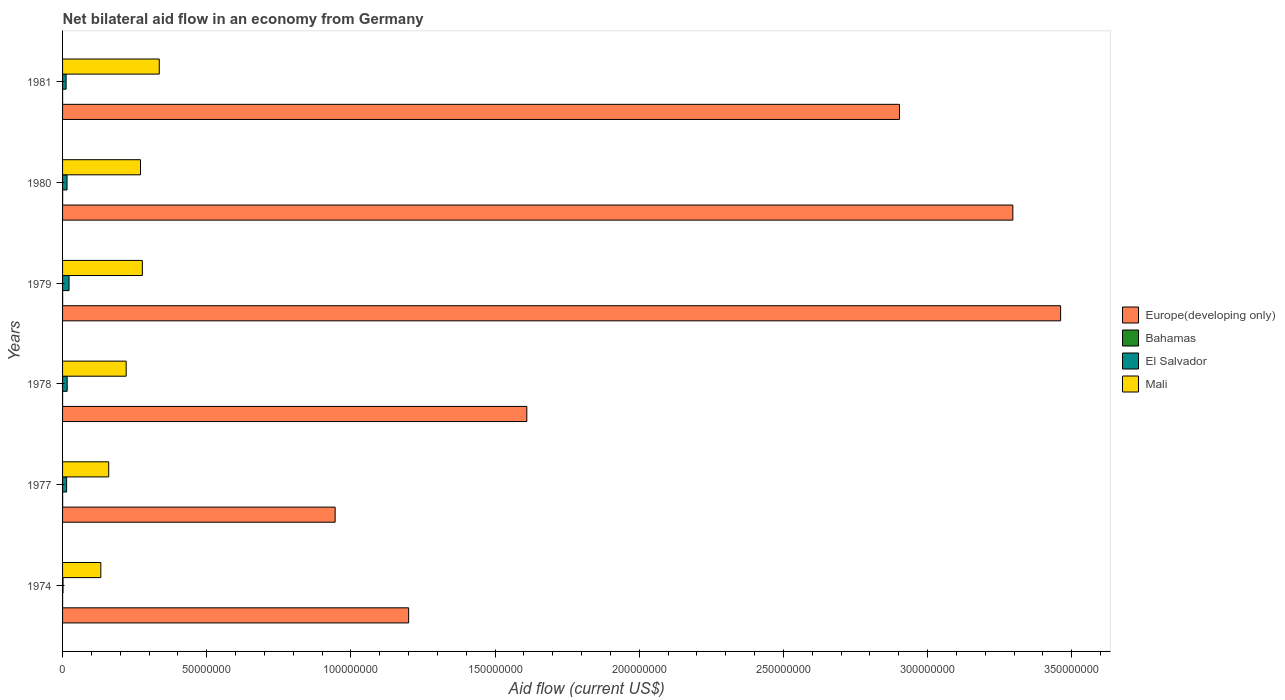How many different coloured bars are there?
Your answer should be compact. 4. Are the number of bars per tick equal to the number of legend labels?
Offer a terse response. Yes. How many bars are there on the 4th tick from the top?
Keep it short and to the point. 4. How many bars are there on the 5th tick from the bottom?
Give a very brief answer. 4. What is the label of the 5th group of bars from the top?
Ensure brevity in your answer.  1977. What is the net bilateral aid flow in Europe(developing only) in 1978?
Your answer should be compact. 1.61e+08. Across all years, what is the maximum net bilateral aid flow in Europe(developing only)?
Ensure brevity in your answer.  3.46e+08. Across all years, what is the minimum net bilateral aid flow in Mali?
Your response must be concise. 1.33e+07. In which year was the net bilateral aid flow in Bahamas maximum?
Your response must be concise. 1977. In which year was the net bilateral aid flow in Mali minimum?
Offer a very short reply. 1974. What is the total net bilateral aid flow in Europe(developing only) in the graph?
Your answer should be very brief. 1.34e+09. What is the difference between the net bilateral aid flow in Mali in 1977 and that in 1978?
Provide a short and direct response. -6.06e+06. What is the difference between the net bilateral aid flow in Mali in 1980 and the net bilateral aid flow in Bahamas in 1978?
Offer a terse response. 2.70e+07. What is the average net bilateral aid flow in Bahamas per year?
Ensure brevity in your answer.  1.50e+04. In the year 1981, what is the difference between the net bilateral aid flow in Bahamas and net bilateral aid flow in Europe(developing only)?
Keep it short and to the point. -2.90e+08. In how many years, is the net bilateral aid flow in Europe(developing only) greater than 290000000 US$?
Offer a terse response. 3. What is the ratio of the net bilateral aid flow in Bahamas in 1978 to that in 1979?
Your response must be concise. 0.5. Is the net bilateral aid flow in El Salvador in 1974 less than that in 1978?
Offer a very short reply. Yes. What is the difference between the highest and the second highest net bilateral aid flow in Europe(developing only)?
Your response must be concise. 1.66e+07. In how many years, is the net bilateral aid flow in Bahamas greater than the average net bilateral aid flow in Bahamas taken over all years?
Your answer should be compact. 3. Is the sum of the net bilateral aid flow in Bahamas in 1977 and 1981 greater than the maximum net bilateral aid flow in El Salvador across all years?
Offer a terse response. No. Is it the case that in every year, the sum of the net bilateral aid flow in Europe(developing only) and net bilateral aid flow in Mali is greater than the sum of net bilateral aid flow in Bahamas and net bilateral aid flow in El Salvador?
Your answer should be compact. No. What does the 4th bar from the top in 1979 represents?
Make the answer very short. Europe(developing only). What does the 2nd bar from the bottom in 1977 represents?
Your answer should be compact. Bahamas. Is it the case that in every year, the sum of the net bilateral aid flow in Bahamas and net bilateral aid flow in Mali is greater than the net bilateral aid flow in Europe(developing only)?
Your answer should be very brief. No. How many bars are there?
Your answer should be compact. 24. Are all the bars in the graph horizontal?
Keep it short and to the point. Yes. How many years are there in the graph?
Offer a very short reply. 6. What is the difference between two consecutive major ticks on the X-axis?
Your answer should be very brief. 5.00e+07. Does the graph contain grids?
Your answer should be very brief. No. How many legend labels are there?
Provide a succinct answer. 4. How are the legend labels stacked?
Make the answer very short. Vertical. What is the title of the graph?
Make the answer very short. Net bilateral aid flow in an economy from Germany. Does "Croatia" appear as one of the legend labels in the graph?
Offer a terse response. No. What is the label or title of the X-axis?
Make the answer very short. Aid flow (current US$). What is the label or title of the Y-axis?
Offer a very short reply. Years. What is the Aid flow (current US$) in Europe(developing only) in 1974?
Provide a short and direct response. 1.20e+08. What is the Aid flow (current US$) in Bahamas in 1974?
Give a very brief answer. 10000. What is the Aid flow (current US$) in El Salvador in 1974?
Offer a very short reply. 1.60e+05. What is the Aid flow (current US$) in Mali in 1974?
Make the answer very short. 1.33e+07. What is the Aid flow (current US$) of Europe(developing only) in 1977?
Ensure brevity in your answer.  9.45e+07. What is the Aid flow (current US$) in El Salvador in 1977?
Your response must be concise. 1.41e+06. What is the Aid flow (current US$) in Mali in 1977?
Your response must be concise. 1.60e+07. What is the Aid flow (current US$) in Europe(developing only) in 1978?
Make the answer very short. 1.61e+08. What is the Aid flow (current US$) in Bahamas in 1978?
Provide a short and direct response. 10000. What is the Aid flow (current US$) of El Salvador in 1978?
Provide a short and direct response. 1.60e+06. What is the Aid flow (current US$) of Mali in 1978?
Your answer should be compact. 2.21e+07. What is the Aid flow (current US$) of Europe(developing only) in 1979?
Give a very brief answer. 3.46e+08. What is the Aid flow (current US$) in Bahamas in 1979?
Ensure brevity in your answer.  2.00e+04. What is the Aid flow (current US$) of El Salvador in 1979?
Keep it short and to the point. 2.25e+06. What is the Aid flow (current US$) in Mali in 1979?
Your answer should be compact. 2.77e+07. What is the Aid flow (current US$) in Europe(developing only) in 1980?
Provide a short and direct response. 3.30e+08. What is the Aid flow (current US$) of El Salvador in 1980?
Provide a succinct answer. 1.55e+06. What is the Aid flow (current US$) in Mali in 1980?
Keep it short and to the point. 2.70e+07. What is the Aid flow (current US$) of Europe(developing only) in 1981?
Your answer should be compact. 2.90e+08. What is the Aid flow (current US$) in El Salvador in 1981?
Make the answer very short. 1.23e+06. What is the Aid flow (current US$) in Mali in 1981?
Give a very brief answer. 3.35e+07. Across all years, what is the maximum Aid flow (current US$) of Europe(developing only)?
Make the answer very short. 3.46e+08. Across all years, what is the maximum Aid flow (current US$) in Bahamas?
Your response must be concise. 2.00e+04. Across all years, what is the maximum Aid flow (current US$) in El Salvador?
Your answer should be very brief. 2.25e+06. Across all years, what is the maximum Aid flow (current US$) in Mali?
Your answer should be compact. 3.35e+07. Across all years, what is the minimum Aid flow (current US$) of Europe(developing only)?
Make the answer very short. 9.45e+07. Across all years, what is the minimum Aid flow (current US$) of El Salvador?
Give a very brief answer. 1.60e+05. Across all years, what is the minimum Aid flow (current US$) of Mali?
Offer a very short reply. 1.33e+07. What is the total Aid flow (current US$) of Europe(developing only) in the graph?
Keep it short and to the point. 1.34e+09. What is the total Aid flow (current US$) of Bahamas in the graph?
Your response must be concise. 9.00e+04. What is the total Aid flow (current US$) of El Salvador in the graph?
Provide a short and direct response. 8.20e+06. What is the total Aid flow (current US$) of Mali in the graph?
Provide a succinct answer. 1.40e+08. What is the difference between the Aid flow (current US$) in Europe(developing only) in 1974 and that in 1977?
Your answer should be very brief. 2.55e+07. What is the difference between the Aid flow (current US$) of Bahamas in 1974 and that in 1977?
Provide a succinct answer. -10000. What is the difference between the Aid flow (current US$) of El Salvador in 1974 and that in 1977?
Give a very brief answer. -1.25e+06. What is the difference between the Aid flow (current US$) of Mali in 1974 and that in 1977?
Offer a very short reply. -2.73e+06. What is the difference between the Aid flow (current US$) of Europe(developing only) in 1974 and that in 1978?
Make the answer very short. -4.10e+07. What is the difference between the Aid flow (current US$) in El Salvador in 1974 and that in 1978?
Provide a succinct answer. -1.44e+06. What is the difference between the Aid flow (current US$) in Mali in 1974 and that in 1978?
Offer a very short reply. -8.79e+06. What is the difference between the Aid flow (current US$) of Europe(developing only) in 1974 and that in 1979?
Your answer should be very brief. -2.26e+08. What is the difference between the Aid flow (current US$) of Bahamas in 1974 and that in 1979?
Keep it short and to the point. -10000. What is the difference between the Aid flow (current US$) of El Salvador in 1974 and that in 1979?
Provide a short and direct response. -2.09e+06. What is the difference between the Aid flow (current US$) of Mali in 1974 and that in 1979?
Your response must be concise. -1.44e+07. What is the difference between the Aid flow (current US$) of Europe(developing only) in 1974 and that in 1980?
Your answer should be very brief. -2.10e+08. What is the difference between the Aid flow (current US$) in Bahamas in 1974 and that in 1980?
Offer a terse response. -10000. What is the difference between the Aid flow (current US$) of El Salvador in 1974 and that in 1980?
Your answer should be very brief. -1.39e+06. What is the difference between the Aid flow (current US$) of Mali in 1974 and that in 1980?
Your answer should be compact. -1.38e+07. What is the difference between the Aid flow (current US$) in Europe(developing only) in 1974 and that in 1981?
Your response must be concise. -1.70e+08. What is the difference between the Aid flow (current US$) in Bahamas in 1974 and that in 1981?
Keep it short and to the point. 0. What is the difference between the Aid flow (current US$) in El Salvador in 1974 and that in 1981?
Provide a succinct answer. -1.07e+06. What is the difference between the Aid flow (current US$) in Mali in 1974 and that in 1981?
Offer a very short reply. -2.03e+07. What is the difference between the Aid flow (current US$) of Europe(developing only) in 1977 and that in 1978?
Your answer should be compact. -6.65e+07. What is the difference between the Aid flow (current US$) in Bahamas in 1977 and that in 1978?
Provide a short and direct response. 10000. What is the difference between the Aid flow (current US$) in Mali in 1977 and that in 1978?
Make the answer very short. -6.06e+06. What is the difference between the Aid flow (current US$) of Europe(developing only) in 1977 and that in 1979?
Your answer should be very brief. -2.52e+08. What is the difference between the Aid flow (current US$) of Bahamas in 1977 and that in 1979?
Make the answer very short. 0. What is the difference between the Aid flow (current US$) in El Salvador in 1977 and that in 1979?
Provide a short and direct response. -8.40e+05. What is the difference between the Aid flow (current US$) of Mali in 1977 and that in 1979?
Provide a succinct answer. -1.17e+07. What is the difference between the Aid flow (current US$) in Europe(developing only) in 1977 and that in 1980?
Give a very brief answer. -2.35e+08. What is the difference between the Aid flow (current US$) in Mali in 1977 and that in 1980?
Your answer should be very brief. -1.10e+07. What is the difference between the Aid flow (current US$) of Europe(developing only) in 1977 and that in 1981?
Make the answer very short. -1.96e+08. What is the difference between the Aid flow (current US$) of Mali in 1977 and that in 1981?
Give a very brief answer. -1.75e+07. What is the difference between the Aid flow (current US$) in Europe(developing only) in 1978 and that in 1979?
Offer a terse response. -1.85e+08. What is the difference between the Aid flow (current US$) in El Salvador in 1978 and that in 1979?
Your response must be concise. -6.50e+05. What is the difference between the Aid flow (current US$) of Mali in 1978 and that in 1979?
Ensure brevity in your answer.  -5.61e+06. What is the difference between the Aid flow (current US$) of Europe(developing only) in 1978 and that in 1980?
Keep it short and to the point. -1.69e+08. What is the difference between the Aid flow (current US$) of El Salvador in 1978 and that in 1980?
Offer a very short reply. 5.00e+04. What is the difference between the Aid flow (current US$) in Mali in 1978 and that in 1980?
Make the answer very short. -4.97e+06. What is the difference between the Aid flow (current US$) in Europe(developing only) in 1978 and that in 1981?
Your response must be concise. -1.29e+08. What is the difference between the Aid flow (current US$) of El Salvador in 1978 and that in 1981?
Provide a short and direct response. 3.70e+05. What is the difference between the Aid flow (current US$) of Mali in 1978 and that in 1981?
Provide a short and direct response. -1.15e+07. What is the difference between the Aid flow (current US$) of Europe(developing only) in 1979 and that in 1980?
Offer a very short reply. 1.66e+07. What is the difference between the Aid flow (current US$) in El Salvador in 1979 and that in 1980?
Provide a short and direct response. 7.00e+05. What is the difference between the Aid flow (current US$) of Mali in 1979 and that in 1980?
Provide a short and direct response. 6.40e+05. What is the difference between the Aid flow (current US$) in Europe(developing only) in 1979 and that in 1981?
Your response must be concise. 5.59e+07. What is the difference between the Aid flow (current US$) in Bahamas in 1979 and that in 1981?
Your response must be concise. 10000. What is the difference between the Aid flow (current US$) in El Salvador in 1979 and that in 1981?
Provide a short and direct response. 1.02e+06. What is the difference between the Aid flow (current US$) in Mali in 1979 and that in 1981?
Your answer should be compact. -5.87e+06. What is the difference between the Aid flow (current US$) in Europe(developing only) in 1980 and that in 1981?
Offer a terse response. 3.93e+07. What is the difference between the Aid flow (current US$) of Bahamas in 1980 and that in 1981?
Make the answer very short. 10000. What is the difference between the Aid flow (current US$) of Mali in 1980 and that in 1981?
Provide a succinct answer. -6.51e+06. What is the difference between the Aid flow (current US$) in Europe(developing only) in 1974 and the Aid flow (current US$) in Bahamas in 1977?
Provide a succinct answer. 1.20e+08. What is the difference between the Aid flow (current US$) in Europe(developing only) in 1974 and the Aid flow (current US$) in El Salvador in 1977?
Your answer should be very brief. 1.19e+08. What is the difference between the Aid flow (current US$) of Europe(developing only) in 1974 and the Aid flow (current US$) of Mali in 1977?
Make the answer very short. 1.04e+08. What is the difference between the Aid flow (current US$) of Bahamas in 1974 and the Aid flow (current US$) of El Salvador in 1977?
Provide a short and direct response. -1.40e+06. What is the difference between the Aid flow (current US$) in Bahamas in 1974 and the Aid flow (current US$) in Mali in 1977?
Give a very brief answer. -1.60e+07. What is the difference between the Aid flow (current US$) in El Salvador in 1974 and the Aid flow (current US$) in Mali in 1977?
Keep it short and to the point. -1.58e+07. What is the difference between the Aid flow (current US$) in Europe(developing only) in 1974 and the Aid flow (current US$) in Bahamas in 1978?
Your answer should be very brief. 1.20e+08. What is the difference between the Aid flow (current US$) in Europe(developing only) in 1974 and the Aid flow (current US$) in El Salvador in 1978?
Provide a short and direct response. 1.18e+08. What is the difference between the Aid flow (current US$) in Europe(developing only) in 1974 and the Aid flow (current US$) in Mali in 1978?
Your response must be concise. 9.80e+07. What is the difference between the Aid flow (current US$) of Bahamas in 1974 and the Aid flow (current US$) of El Salvador in 1978?
Give a very brief answer. -1.59e+06. What is the difference between the Aid flow (current US$) in Bahamas in 1974 and the Aid flow (current US$) in Mali in 1978?
Ensure brevity in your answer.  -2.20e+07. What is the difference between the Aid flow (current US$) of El Salvador in 1974 and the Aid flow (current US$) of Mali in 1978?
Provide a succinct answer. -2.19e+07. What is the difference between the Aid flow (current US$) of Europe(developing only) in 1974 and the Aid flow (current US$) of Bahamas in 1979?
Your answer should be compact. 1.20e+08. What is the difference between the Aid flow (current US$) of Europe(developing only) in 1974 and the Aid flow (current US$) of El Salvador in 1979?
Ensure brevity in your answer.  1.18e+08. What is the difference between the Aid flow (current US$) in Europe(developing only) in 1974 and the Aid flow (current US$) in Mali in 1979?
Your response must be concise. 9.24e+07. What is the difference between the Aid flow (current US$) of Bahamas in 1974 and the Aid flow (current US$) of El Salvador in 1979?
Your answer should be compact. -2.24e+06. What is the difference between the Aid flow (current US$) in Bahamas in 1974 and the Aid flow (current US$) in Mali in 1979?
Provide a short and direct response. -2.77e+07. What is the difference between the Aid flow (current US$) of El Salvador in 1974 and the Aid flow (current US$) of Mali in 1979?
Ensure brevity in your answer.  -2.75e+07. What is the difference between the Aid flow (current US$) in Europe(developing only) in 1974 and the Aid flow (current US$) in Bahamas in 1980?
Your answer should be very brief. 1.20e+08. What is the difference between the Aid flow (current US$) in Europe(developing only) in 1974 and the Aid flow (current US$) in El Salvador in 1980?
Give a very brief answer. 1.18e+08. What is the difference between the Aid flow (current US$) of Europe(developing only) in 1974 and the Aid flow (current US$) of Mali in 1980?
Offer a terse response. 9.30e+07. What is the difference between the Aid flow (current US$) of Bahamas in 1974 and the Aid flow (current US$) of El Salvador in 1980?
Provide a short and direct response. -1.54e+06. What is the difference between the Aid flow (current US$) in Bahamas in 1974 and the Aid flow (current US$) in Mali in 1980?
Give a very brief answer. -2.70e+07. What is the difference between the Aid flow (current US$) of El Salvador in 1974 and the Aid flow (current US$) of Mali in 1980?
Your response must be concise. -2.69e+07. What is the difference between the Aid flow (current US$) in Europe(developing only) in 1974 and the Aid flow (current US$) in Bahamas in 1981?
Offer a terse response. 1.20e+08. What is the difference between the Aid flow (current US$) in Europe(developing only) in 1974 and the Aid flow (current US$) in El Salvador in 1981?
Make the answer very short. 1.19e+08. What is the difference between the Aid flow (current US$) in Europe(developing only) in 1974 and the Aid flow (current US$) in Mali in 1981?
Offer a terse response. 8.65e+07. What is the difference between the Aid flow (current US$) in Bahamas in 1974 and the Aid flow (current US$) in El Salvador in 1981?
Your answer should be very brief. -1.22e+06. What is the difference between the Aid flow (current US$) of Bahamas in 1974 and the Aid flow (current US$) of Mali in 1981?
Provide a short and direct response. -3.35e+07. What is the difference between the Aid flow (current US$) in El Salvador in 1974 and the Aid flow (current US$) in Mali in 1981?
Ensure brevity in your answer.  -3.34e+07. What is the difference between the Aid flow (current US$) of Europe(developing only) in 1977 and the Aid flow (current US$) of Bahamas in 1978?
Make the answer very short. 9.45e+07. What is the difference between the Aid flow (current US$) in Europe(developing only) in 1977 and the Aid flow (current US$) in El Salvador in 1978?
Offer a very short reply. 9.29e+07. What is the difference between the Aid flow (current US$) of Europe(developing only) in 1977 and the Aid flow (current US$) of Mali in 1978?
Offer a terse response. 7.25e+07. What is the difference between the Aid flow (current US$) of Bahamas in 1977 and the Aid flow (current US$) of El Salvador in 1978?
Give a very brief answer. -1.58e+06. What is the difference between the Aid flow (current US$) in Bahamas in 1977 and the Aid flow (current US$) in Mali in 1978?
Provide a short and direct response. -2.20e+07. What is the difference between the Aid flow (current US$) of El Salvador in 1977 and the Aid flow (current US$) of Mali in 1978?
Provide a short and direct response. -2.06e+07. What is the difference between the Aid flow (current US$) of Europe(developing only) in 1977 and the Aid flow (current US$) of Bahamas in 1979?
Give a very brief answer. 9.45e+07. What is the difference between the Aid flow (current US$) of Europe(developing only) in 1977 and the Aid flow (current US$) of El Salvador in 1979?
Ensure brevity in your answer.  9.23e+07. What is the difference between the Aid flow (current US$) in Europe(developing only) in 1977 and the Aid flow (current US$) in Mali in 1979?
Your answer should be very brief. 6.69e+07. What is the difference between the Aid flow (current US$) of Bahamas in 1977 and the Aid flow (current US$) of El Salvador in 1979?
Your answer should be very brief. -2.23e+06. What is the difference between the Aid flow (current US$) in Bahamas in 1977 and the Aid flow (current US$) in Mali in 1979?
Ensure brevity in your answer.  -2.76e+07. What is the difference between the Aid flow (current US$) in El Salvador in 1977 and the Aid flow (current US$) in Mali in 1979?
Your answer should be compact. -2.63e+07. What is the difference between the Aid flow (current US$) in Europe(developing only) in 1977 and the Aid flow (current US$) in Bahamas in 1980?
Make the answer very short. 9.45e+07. What is the difference between the Aid flow (current US$) of Europe(developing only) in 1977 and the Aid flow (current US$) of El Salvador in 1980?
Offer a very short reply. 9.30e+07. What is the difference between the Aid flow (current US$) of Europe(developing only) in 1977 and the Aid flow (current US$) of Mali in 1980?
Provide a succinct answer. 6.75e+07. What is the difference between the Aid flow (current US$) in Bahamas in 1977 and the Aid flow (current US$) in El Salvador in 1980?
Give a very brief answer. -1.53e+06. What is the difference between the Aid flow (current US$) of Bahamas in 1977 and the Aid flow (current US$) of Mali in 1980?
Make the answer very short. -2.70e+07. What is the difference between the Aid flow (current US$) of El Salvador in 1977 and the Aid flow (current US$) of Mali in 1980?
Offer a very short reply. -2.56e+07. What is the difference between the Aid flow (current US$) of Europe(developing only) in 1977 and the Aid flow (current US$) of Bahamas in 1981?
Your answer should be compact. 9.45e+07. What is the difference between the Aid flow (current US$) in Europe(developing only) in 1977 and the Aid flow (current US$) in El Salvador in 1981?
Your answer should be very brief. 9.33e+07. What is the difference between the Aid flow (current US$) in Europe(developing only) in 1977 and the Aid flow (current US$) in Mali in 1981?
Your answer should be very brief. 6.10e+07. What is the difference between the Aid flow (current US$) in Bahamas in 1977 and the Aid flow (current US$) in El Salvador in 1981?
Keep it short and to the point. -1.21e+06. What is the difference between the Aid flow (current US$) in Bahamas in 1977 and the Aid flow (current US$) in Mali in 1981?
Offer a very short reply. -3.35e+07. What is the difference between the Aid flow (current US$) in El Salvador in 1977 and the Aid flow (current US$) in Mali in 1981?
Ensure brevity in your answer.  -3.21e+07. What is the difference between the Aid flow (current US$) in Europe(developing only) in 1978 and the Aid flow (current US$) in Bahamas in 1979?
Give a very brief answer. 1.61e+08. What is the difference between the Aid flow (current US$) in Europe(developing only) in 1978 and the Aid flow (current US$) in El Salvador in 1979?
Provide a succinct answer. 1.59e+08. What is the difference between the Aid flow (current US$) of Europe(developing only) in 1978 and the Aid flow (current US$) of Mali in 1979?
Provide a succinct answer. 1.33e+08. What is the difference between the Aid flow (current US$) of Bahamas in 1978 and the Aid flow (current US$) of El Salvador in 1979?
Ensure brevity in your answer.  -2.24e+06. What is the difference between the Aid flow (current US$) in Bahamas in 1978 and the Aid flow (current US$) in Mali in 1979?
Offer a terse response. -2.77e+07. What is the difference between the Aid flow (current US$) of El Salvador in 1978 and the Aid flow (current US$) of Mali in 1979?
Your response must be concise. -2.61e+07. What is the difference between the Aid flow (current US$) in Europe(developing only) in 1978 and the Aid flow (current US$) in Bahamas in 1980?
Your response must be concise. 1.61e+08. What is the difference between the Aid flow (current US$) of Europe(developing only) in 1978 and the Aid flow (current US$) of El Salvador in 1980?
Your response must be concise. 1.59e+08. What is the difference between the Aid flow (current US$) in Europe(developing only) in 1978 and the Aid flow (current US$) in Mali in 1980?
Your answer should be very brief. 1.34e+08. What is the difference between the Aid flow (current US$) of Bahamas in 1978 and the Aid flow (current US$) of El Salvador in 1980?
Make the answer very short. -1.54e+06. What is the difference between the Aid flow (current US$) in Bahamas in 1978 and the Aid flow (current US$) in Mali in 1980?
Your response must be concise. -2.70e+07. What is the difference between the Aid flow (current US$) in El Salvador in 1978 and the Aid flow (current US$) in Mali in 1980?
Offer a terse response. -2.54e+07. What is the difference between the Aid flow (current US$) of Europe(developing only) in 1978 and the Aid flow (current US$) of Bahamas in 1981?
Your answer should be very brief. 1.61e+08. What is the difference between the Aid flow (current US$) of Europe(developing only) in 1978 and the Aid flow (current US$) of El Salvador in 1981?
Your answer should be compact. 1.60e+08. What is the difference between the Aid flow (current US$) of Europe(developing only) in 1978 and the Aid flow (current US$) of Mali in 1981?
Offer a terse response. 1.27e+08. What is the difference between the Aid flow (current US$) in Bahamas in 1978 and the Aid flow (current US$) in El Salvador in 1981?
Ensure brevity in your answer.  -1.22e+06. What is the difference between the Aid flow (current US$) in Bahamas in 1978 and the Aid flow (current US$) in Mali in 1981?
Make the answer very short. -3.35e+07. What is the difference between the Aid flow (current US$) in El Salvador in 1978 and the Aid flow (current US$) in Mali in 1981?
Your response must be concise. -3.19e+07. What is the difference between the Aid flow (current US$) of Europe(developing only) in 1979 and the Aid flow (current US$) of Bahamas in 1980?
Give a very brief answer. 3.46e+08. What is the difference between the Aid flow (current US$) of Europe(developing only) in 1979 and the Aid flow (current US$) of El Salvador in 1980?
Provide a succinct answer. 3.45e+08. What is the difference between the Aid flow (current US$) of Europe(developing only) in 1979 and the Aid flow (current US$) of Mali in 1980?
Make the answer very short. 3.19e+08. What is the difference between the Aid flow (current US$) in Bahamas in 1979 and the Aid flow (current US$) in El Salvador in 1980?
Offer a terse response. -1.53e+06. What is the difference between the Aid flow (current US$) in Bahamas in 1979 and the Aid flow (current US$) in Mali in 1980?
Offer a very short reply. -2.70e+07. What is the difference between the Aid flow (current US$) of El Salvador in 1979 and the Aid flow (current US$) of Mali in 1980?
Your response must be concise. -2.48e+07. What is the difference between the Aid flow (current US$) of Europe(developing only) in 1979 and the Aid flow (current US$) of Bahamas in 1981?
Offer a terse response. 3.46e+08. What is the difference between the Aid flow (current US$) of Europe(developing only) in 1979 and the Aid flow (current US$) of El Salvador in 1981?
Provide a short and direct response. 3.45e+08. What is the difference between the Aid flow (current US$) in Europe(developing only) in 1979 and the Aid flow (current US$) in Mali in 1981?
Give a very brief answer. 3.13e+08. What is the difference between the Aid flow (current US$) of Bahamas in 1979 and the Aid flow (current US$) of El Salvador in 1981?
Provide a succinct answer. -1.21e+06. What is the difference between the Aid flow (current US$) of Bahamas in 1979 and the Aid flow (current US$) of Mali in 1981?
Offer a terse response. -3.35e+07. What is the difference between the Aid flow (current US$) in El Salvador in 1979 and the Aid flow (current US$) in Mali in 1981?
Provide a short and direct response. -3.13e+07. What is the difference between the Aid flow (current US$) in Europe(developing only) in 1980 and the Aid flow (current US$) in Bahamas in 1981?
Make the answer very short. 3.30e+08. What is the difference between the Aid flow (current US$) in Europe(developing only) in 1980 and the Aid flow (current US$) in El Salvador in 1981?
Keep it short and to the point. 3.28e+08. What is the difference between the Aid flow (current US$) in Europe(developing only) in 1980 and the Aid flow (current US$) in Mali in 1981?
Provide a succinct answer. 2.96e+08. What is the difference between the Aid flow (current US$) of Bahamas in 1980 and the Aid flow (current US$) of El Salvador in 1981?
Offer a terse response. -1.21e+06. What is the difference between the Aid flow (current US$) in Bahamas in 1980 and the Aid flow (current US$) in Mali in 1981?
Keep it short and to the point. -3.35e+07. What is the difference between the Aid flow (current US$) of El Salvador in 1980 and the Aid flow (current US$) of Mali in 1981?
Your response must be concise. -3.20e+07. What is the average Aid flow (current US$) in Europe(developing only) per year?
Ensure brevity in your answer.  2.24e+08. What is the average Aid flow (current US$) of Bahamas per year?
Make the answer very short. 1.50e+04. What is the average Aid flow (current US$) in El Salvador per year?
Your answer should be compact. 1.37e+06. What is the average Aid flow (current US$) of Mali per year?
Keep it short and to the point. 2.33e+07. In the year 1974, what is the difference between the Aid flow (current US$) in Europe(developing only) and Aid flow (current US$) in Bahamas?
Offer a very short reply. 1.20e+08. In the year 1974, what is the difference between the Aid flow (current US$) of Europe(developing only) and Aid flow (current US$) of El Salvador?
Provide a short and direct response. 1.20e+08. In the year 1974, what is the difference between the Aid flow (current US$) in Europe(developing only) and Aid flow (current US$) in Mali?
Provide a short and direct response. 1.07e+08. In the year 1974, what is the difference between the Aid flow (current US$) in Bahamas and Aid flow (current US$) in El Salvador?
Make the answer very short. -1.50e+05. In the year 1974, what is the difference between the Aid flow (current US$) in Bahamas and Aid flow (current US$) in Mali?
Provide a short and direct response. -1.33e+07. In the year 1974, what is the difference between the Aid flow (current US$) of El Salvador and Aid flow (current US$) of Mali?
Provide a succinct answer. -1.31e+07. In the year 1977, what is the difference between the Aid flow (current US$) in Europe(developing only) and Aid flow (current US$) in Bahamas?
Your response must be concise. 9.45e+07. In the year 1977, what is the difference between the Aid flow (current US$) in Europe(developing only) and Aid flow (current US$) in El Salvador?
Keep it short and to the point. 9.31e+07. In the year 1977, what is the difference between the Aid flow (current US$) of Europe(developing only) and Aid flow (current US$) of Mali?
Keep it short and to the point. 7.85e+07. In the year 1977, what is the difference between the Aid flow (current US$) in Bahamas and Aid flow (current US$) in El Salvador?
Make the answer very short. -1.39e+06. In the year 1977, what is the difference between the Aid flow (current US$) in Bahamas and Aid flow (current US$) in Mali?
Offer a very short reply. -1.60e+07. In the year 1977, what is the difference between the Aid flow (current US$) of El Salvador and Aid flow (current US$) of Mali?
Offer a very short reply. -1.46e+07. In the year 1978, what is the difference between the Aid flow (current US$) of Europe(developing only) and Aid flow (current US$) of Bahamas?
Offer a terse response. 1.61e+08. In the year 1978, what is the difference between the Aid flow (current US$) of Europe(developing only) and Aid flow (current US$) of El Salvador?
Ensure brevity in your answer.  1.59e+08. In the year 1978, what is the difference between the Aid flow (current US$) in Europe(developing only) and Aid flow (current US$) in Mali?
Offer a very short reply. 1.39e+08. In the year 1978, what is the difference between the Aid flow (current US$) of Bahamas and Aid flow (current US$) of El Salvador?
Your response must be concise. -1.59e+06. In the year 1978, what is the difference between the Aid flow (current US$) in Bahamas and Aid flow (current US$) in Mali?
Provide a short and direct response. -2.20e+07. In the year 1978, what is the difference between the Aid flow (current US$) in El Salvador and Aid flow (current US$) in Mali?
Provide a succinct answer. -2.05e+07. In the year 1979, what is the difference between the Aid flow (current US$) in Europe(developing only) and Aid flow (current US$) in Bahamas?
Your answer should be compact. 3.46e+08. In the year 1979, what is the difference between the Aid flow (current US$) of Europe(developing only) and Aid flow (current US$) of El Salvador?
Offer a terse response. 3.44e+08. In the year 1979, what is the difference between the Aid flow (current US$) in Europe(developing only) and Aid flow (current US$) in Mali?
Your answer should be very brief. 3.18e+08. In the year 1979, what is the difference between the Aid flow (current US$) in Bahamas and Aid flow (current US$) in El Salvador?
Your answer should be compact. -2.23e+06. In the year 1979, what is the difference between the Aid flow (current US$) of Bahamas and Aid flow (current US$) of Mali?
Your answer should be very brief. -2.76e+07. In the year 1979, what is the difference between the Aid flow (current US$) in El Salvador and Aid flow (current US$) in Mali?
Your answer should be compact. -2.54e+07. In the year 1980, what is the difference between the Aid flow (current US$) of Europe(developing only) and Aid flow (current US$) of Bahamas?
Keep it short and to the point. 3.30e+08. In the year 1980, what is the difference between the Aid flow (current US$) of Europe(developing only) and Aid flow (current US$) of El Salvador?
Your response must be concise. 3.28e+08. In the year 1980, what is the difference between the Aid flow (current US$) in Europe(developing only) and Aid flow (current US$) in Mali?
Keep it short and to the point. 3.03e+08. In the year 1980, what is the difference between the Aid flow (current US$) of Bahamas and Aid flow (current US$) of El Salvador?
Provide a short and direct response. -1.53e+06. In the year 1980, what is the difference between the Aid flow (current US$) in Bahamas and Aid flow (current US$) in Mali?
Provide a succinct answer. -2.70e+07. In the year 1980, what is the difference between the Aid flow (current US$) of El Salvador and Aid flow (current US$) of Mali?
Offer a very short reply. -2.55e+07. In the year 1981, what is the difference between the Aid flow (current US$) in Europe(developing only) and Aid flow (current US$) in Bahamas?
Ensure brevity in your answer.  2.90e+08. In the year 1981, what is the difference between the Aid flow (current US$) of Europe(developing only) and Aid flow (current US$) of El Salvador?
Give a very brief answer. 2.89e+08. In the year 1981, what is the difference between the Aid flow (current US$) of Europe(developing only) and Aid flow (current US$) of Mali?
Provide a succinct answer. 2.57e+08. In the year 1981, what is the difference between the Aid flow (current US$) of Bahamas and Aid flow (current US$) of El Salvador?
Offer a terse response. -1.22e+06. In the year 1981, what is the difference between the Aid flow (current US$) of Bahamas and Aid flow (current US$) of Mali?
Keep it short and to the point. -3.35e+07. In the year 1981, what is the difference between the Aid flow (current US$) in El Salvador and Aid flow (current US$) in Mali?
Your answer should be very brief. -3.23e+07. What is the ratio of the Aid flow (current US$) in Europe(developing only) in 1974 to that in 1977?
Ensure brevity in your answer.  1.27. What is the ratio of the Aid flow (current US$) in Bahamas in 1974 to that in 1977?
Ensure brevity in your answer.  0.5. What is the ratio of the Aid flow (current US$) of El Salvador in 1974 to that in 1977?
Give a very brief answer. 0.11. What is the ratio of the Aid flow (current US$) of Mali in 1974 to that in 1977?
Ensure brevity in your answer.  0.83. What is the ratio of the Aid flow (current US$) in Europe(developing only) in 1974 to that in 1978?
Offer a terse response. 0.75. What is the ratio of the Aid flow (current US$) of Bahamas in 1974 to that in 1978?
Provide a succinct answer. 1. What is the ratio of the Aid flow (current US$) of El Salvador in 1974 to that in 1978?
Offer a terse response. 0.1. What is the ratio of the Aid flow (current US$) of Mali in 1974 to that in 1978?
Provide a succinct answer. 0.6. What is the ratio of the Aid flow (current US$) of Europe(developing only) in 1974 to that in 1979?
Your answer should be very brief. 0.35. What is the ratio of the Aid flow (current US$) in Bahamas in 1974 to that in 1979?
Your response must be concise. 0.5. What is the ratio of the Aid flow (current US$) in El Salvador in 1974 to that in 1979?
Provide a short and direct response. 0.07. What is the ratio of the Aid flow (current US$) in Mali in 1974 to that in 1979?
Your answer should be compact. 0.48. What is the ratio of the Aid flow (current US$) of Europe(developing only) in 1974 to that in 1980?
Your answer should be very brief. 0.36. What is the ratio of the Aid flow (current US$) of Bahamas in 1974 to that in 1980?
Provide a succinct answer. 0.5. What is the ratio of the Aid flow (current US$) of El Salvador in 1974 to that in 1980?
Your answer should be compact. 0.1. What is the ratio of the Aid flow (current US$) of Mali in 1974 to that in 1980?
Provide a succinct answer. 0.49. What is the ratio of the Aid flow (current US$) in Europe(developing only) in 1974 to that in 1981?
Your answer should be very brief. 0.41. What is the ratio of the Aid flow (current US$) in Bahamas in 1974 to that in 1981?
Offer a very short reply. 1. What is the ratio of the Aid flow (current US$) in El Salvador in 1974 to that in 1981?
Keep it short and to the point. 0.13. What is the ratio of the Aid flow (current US$) of Mali in 1974 to that in 1981?
Give a very brief answer. 0.4. What is the ratio of the Aid flow (current US$) of Europe(developing only) in 1977 to that in 1978?
Your response must be concise. 0.59. What is the ratio of the Aid flow (current US$) in Bahamas in 1977 to that in 1978?
Ensure brevity in your answer.  2. What is the ratio of the Aid flow (current US$) of El Salvador in 1977 to that in 1978?
Your response must be concise. 0.88. What is the ratio of the Aid flow (current US$) of Mali in 1977 to that in 1978?
Offer a very short reply. 0.73. What is the ratio of the Aid flow (current US$) in Europe(developing only) in 1977 to that in 1979?
Provide a succinct answer. 0.27. What is the ratio of the Aid flow (current US$) in El Salvador in 1977 to that in 1979?
Your answer should be very brief. 0.63. What is the ratio of the Aid flow (current US$) of Mali in 1977 to that in 1979?
Your answer should be compact. 0.58. What is the ratio of the Aid flow (current US$) of Europe(developing only) in 1977 to that in 1980?
Your answer should be very brief. 0.29. What is the ratio of the Aid flow (current US$) in Bahamas in 1977 to that in 1980?
Your answer should be compact. 1. What is the ratio of the Aid flow (current US$) in El Salvador in 1977 to that in 1980?
Ensure brevity in your answer.  0.91. What is the ratio of the Aid flow (current US$) of Mali in 1977 to that in 1980?
Keep it short and to the point. 0.59. What is the ratio of the Aid flow (current US$) in Europe(developing only) in 1977 to that in 1981?
Offer a terse response. 0.33. What is the ratio of the Aid flow (current US$) of El Salvador in 1977 to that in 1981?
Keep it short and to the point. 1.15. What is the ratio of the Aid flow (current US$) of Mali in 1977 to that in 1981?
Your response must be concise. 0.48. What is the ratio of the Aid flow (current US$) in Europe(developing only) in 1978 to that in 1979?
Give a very brief answer. 0.47. What is the ratio of the Aid flow (current US$) of El Salvador in 1978 to that in 1979?
Give a very brief answer. 0.71. What is the ratio of the Aid flow (current US$) of Mali in 1978 to that in 1979?
Your response must be concise. 0.8. What is the ratio of the Aid flow (current US$) of Europe(developing only) in 1978 to that in 1980?
Your response must be concise. 0.49. What is the ratio of the Aid flow (current US$) of Bahamas in 1978 to that in 1980?
Your answer should be very brief. 0.5. What is the ratio of the Aid flow (current US$) of El Salvador in 1978 to that in 1980?
Make the answer very short. 1.03. What is the ratio of the Aid flow (current US$) of Mali in 1978 to that in 1980?
Offer a very short reply. 0.82. What is the ratio of the Aid flow (current US$) of Europe(developing only) in 1978 to that in 1981?
Your answer should be very brief. 0.55. What is the ratio of the Aid flow (current US$) of Bahamas in 1978 to that in 1981?
Your response must be concise. 1. What is the ratio of the Aid flow (current US$) of El Salvador in 1978 to that in 1981?
Keep it short and to the point. 1.3. What is the ratio of the Aid flow (current US$) in Mali in 1978 to that in 1981?
Your answer should be compact. 0.66. What is the ratio of the Aid flow (current US$) in Europe(developing only) in 1979 to that in 1980?
Provide a succinct answer. 1.05. What is the ratio of the Aid flow (current US$) of El Salvador in 1979 to that in 1980?
Offer a very short reply. 1.45. What is the ratio of the Aid flow (current US$) in Mali in 1979 to that in 1980?
Provide a succinct answer. 1.02. What is the ratio of the Aid flow (current US$) in Europe(developing only) in 1979 to that in 1981?
Give a very brief answer. 1.19. What is the ratio of the Aid flow (current US$) of El Salvador in 1979 to that in 1981?
Provide a succinct answer. 1.83. What is the ratio of the Aid flow (current US$) in Mali in 1979 to that in 1981?
Keep it short and to the point. 0.82. What is the ratio of the Aid flow (current US$) of Europe(developing only) in 1980 to that in 1981?
Your answer should be very brief. 1.14. What is the ratio of the Aid flow (current US$) in Bahamas in 1980 to that in 1981?
Keep it short and to the point. 2. What is the ratio of the Aid flow (current US$) of El Salvador in 1980 to that in 1981?
Provide a short and direct response. 1.26. What is the ratio of the Aid flow (current US$) of Mali in 1980 to that in 1981?
Offer a very short reply. 0.81. What is the difference between the highest and the second highest Aid flow (current US$) in Europe(developing only)?
Keep it short and to the point. 1.66e+07. What is the difference between the highest and the second highest Aid flow (current US$) of Bahamas?
Keep it short and to the point. 0. What is the difference between the highest and the second highest Aid flow (current US$) in El Salvador?
Your response must be concise. 6.50e+05. What is the difference between the highest and the second highest Aid flow (current US$) in Mali?
Offer a very short reply. 5.87e+06. What is the difference between the highest and the lowest Aid flow (current US$) in Europe(developing only)?
Offer a terse response. 2.52e+08. What is the difference between the highest and the lowest Aid flow (current US$) in Bahamas?
Offer a terse response. 10000. What is the difference between the highest and the lowest Aid flow (current US$) in El Salvador?
Provide a short and direct response. 2.09e+06. What is the difference between the highest and the lowest Aid flow (current US$) of Mali?
Your answer should be very brief. 2.03e+07. 